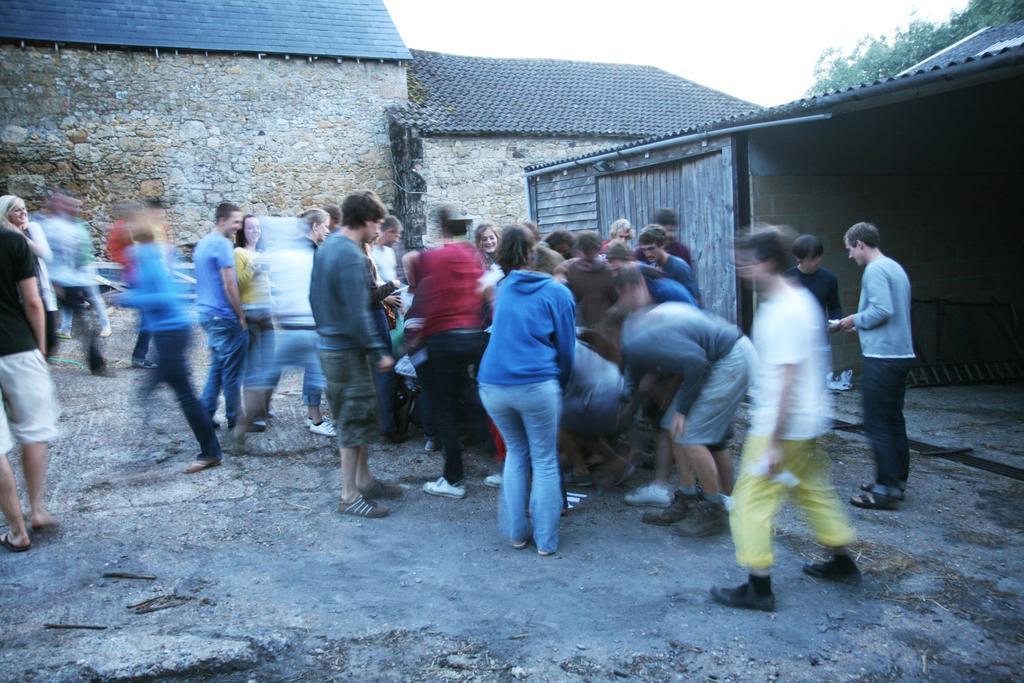Can you describe this image briefly? In this image I can see a crowd on the road. In the background I can see a shed, houses and trees. On the top I can see the sky. This image is taken during a day. 